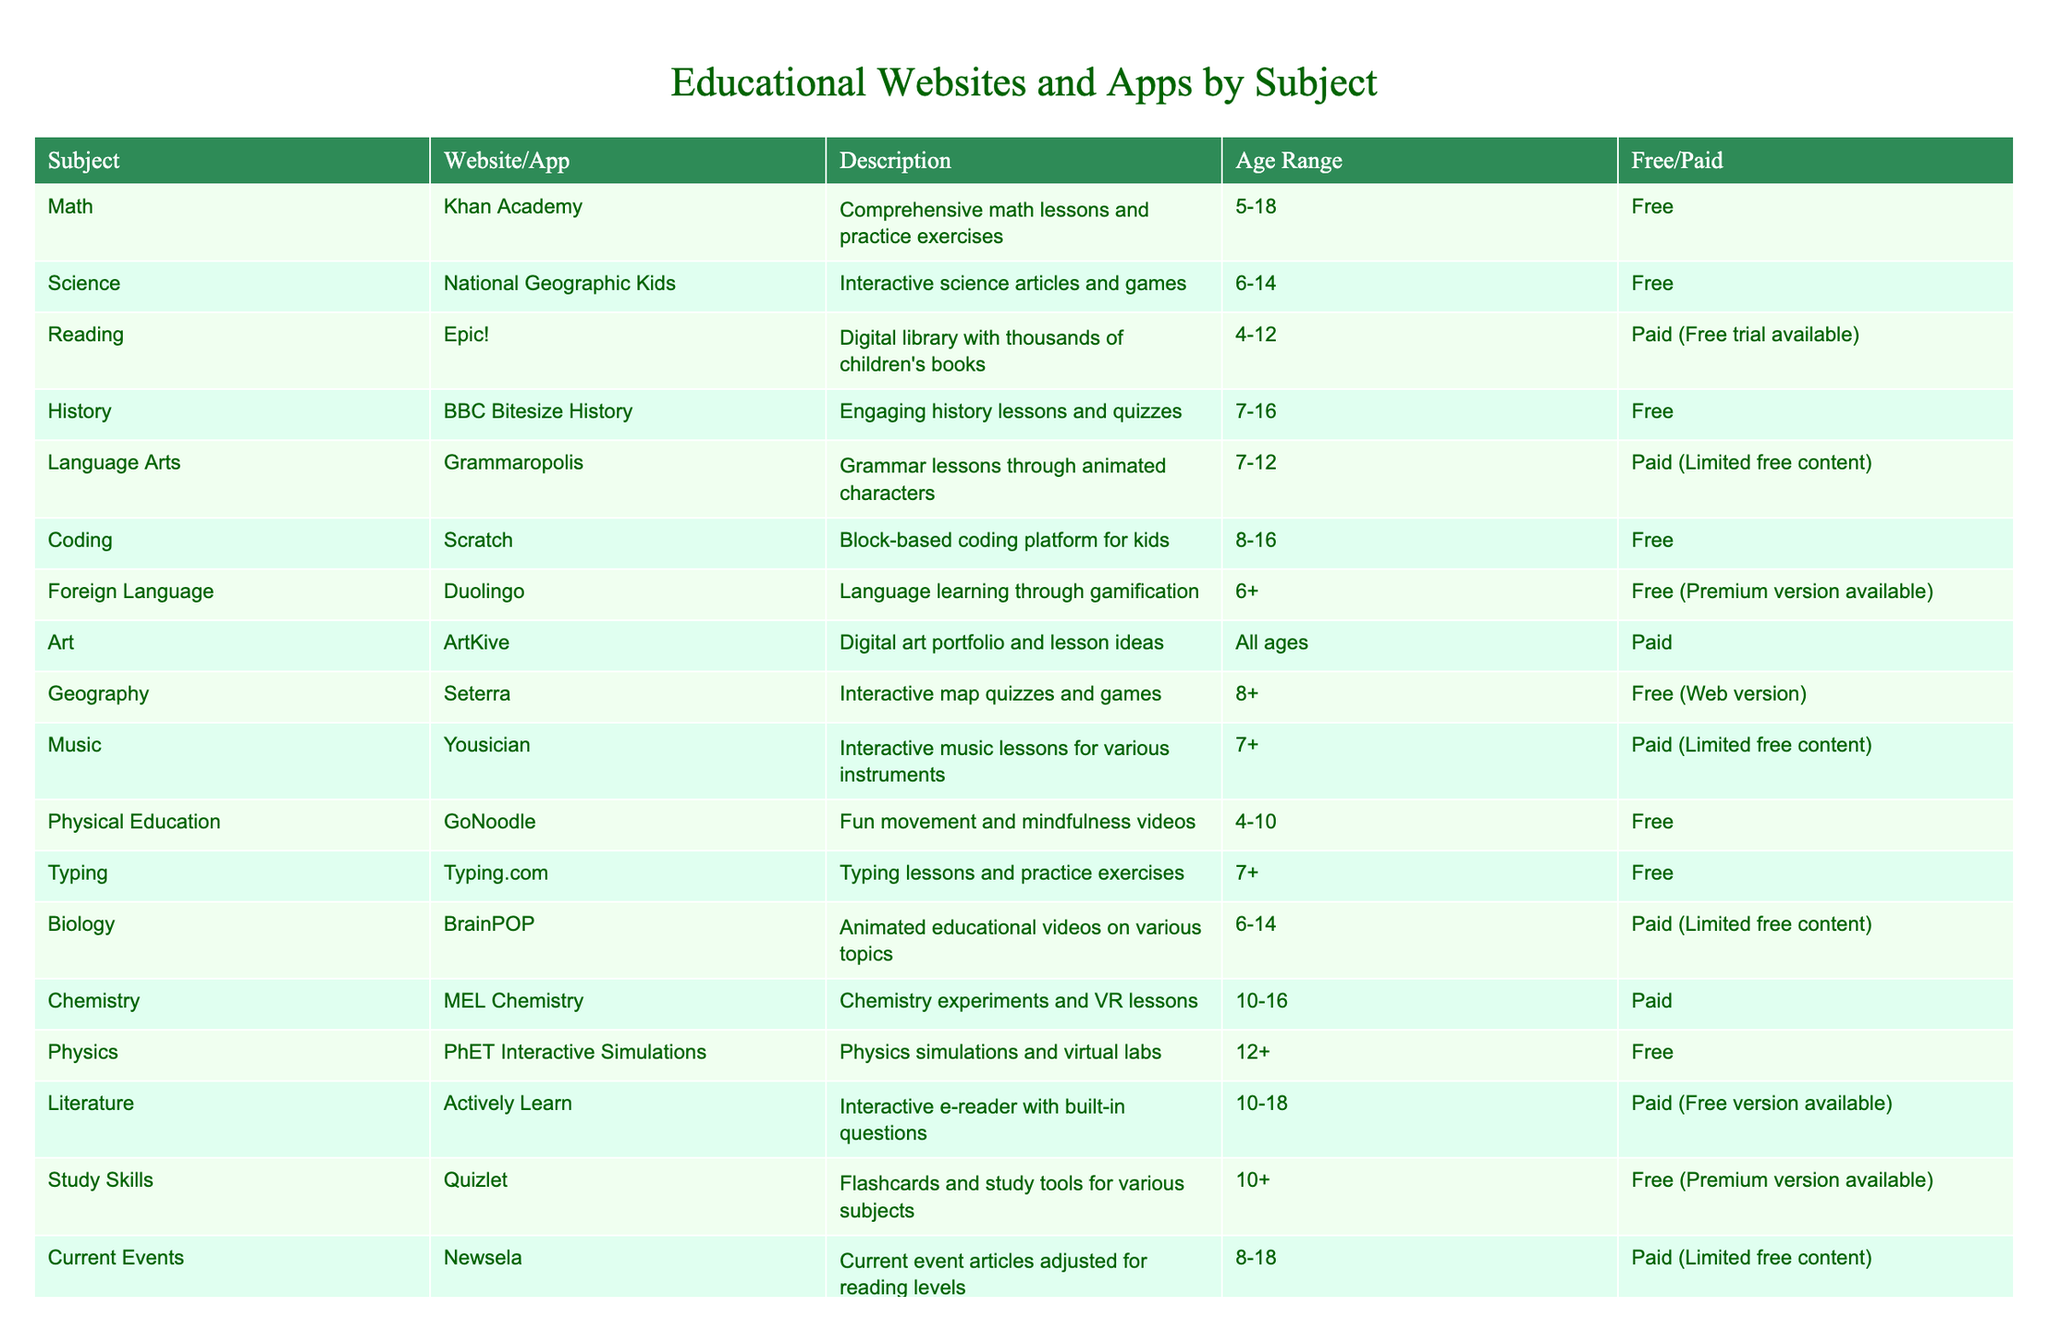What is the age range for the website Khan Academy? The age range for Khan Academy is specified in the table under the "Age Range" column, which states it is for ages 5-18.
Answer: 5-18 Which subjects have free resources available? By reviewing the "Free/Paid" column in the table, the subjects with free resources are Math, Science, History, Coding, Foreign Language, Physical Education, Typing, Physics, and Study Skills.
Answer: Math, Science, History, Coding, Foreign Language, Physical Education, Typing, Physics, Study Skills How many paid resources are available for children ages 6-14? Looking at the age range of 6-14 and checking the "Free/Paid" column, the paid resources are Epic!, BrainPOP, MEL Chemistry, and Newsela. There are 4 paid resources for this age group.
Answer: 4 True or False: ArtKive is a free resource. The "Free/Paid" column indicates that ArtKive is a paid resource, therefore the statement is false.
Answer: False Which subject has the youngest age range, and what is that age range? By checking the "Age Range" column for all subjects, Physical Education has the youngest age range of 4-10.
Answer: 4-10 What is the total number of subjects listed in the table? Counting each subject in the "Subject" column, we find there are 12 subjects listed in the table.
Answer: 12 List the paid resources that have limited free content. From the "Free/Paid" column, the paid resources with limited free content are Grammaropolis, Yousician, BrainPOP, and Newsela.
Answer: Grammaropolis, Yousician, BrainPOP, Newsela Which subject has the most websites/apps available? By evaluating the table, it is noticeable that there is only one website listed per subject, implying all subjects have one website/app each.
Answer: Each subject has one website/app What is the average age range of websites/apps listed for subjects that are coding or science-related? The age ranges for Scratch (8-16) and National Geographic Kids (6-14) are considered. For average calculation: (8+16+6+14)/(4) = 11. Therefore, the average age range is from 6 to 16, roughly reaching 11.
Answer: 11 Which subjects can be accessed by children aged 10 and older? Reviewing the "Age Range" column, the subjects that allow access for children aged 10 and older are Chemistry, Physics, Literature, Study Skills, and Current Events, totaling 5 subjects.
Answer: 5 